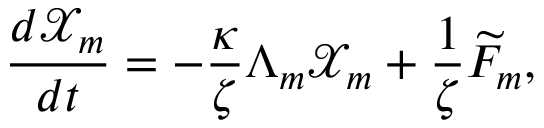Convert formula to latex. <formula><loc_0><loc_0><loc_500><loc_500>\frac { d \mathcal { X } _ { m } } { d t } = - \frac { \kappa } { \zeta } \Lambda _ { m } \mathcal { X } _ { m } + \frac { 1 } { \zeta } \widetilde { F } _ { m } ,</formula> 